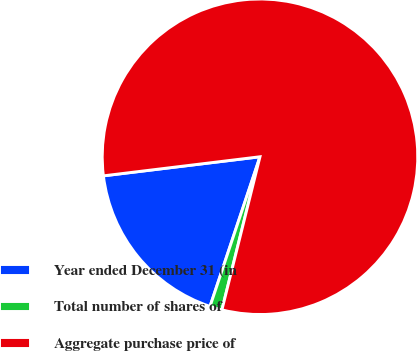Convert chart. <chart><loc_0><loc_0><loc_500><loc_500><pie_chart><fcel>Year ended December 31 (in<fcel>Total number of shares of<fcel>Aggregate purchase price of<nl><fcel>17.94%<fcel>1.25%<fcel>80.81%<nl></chart> 